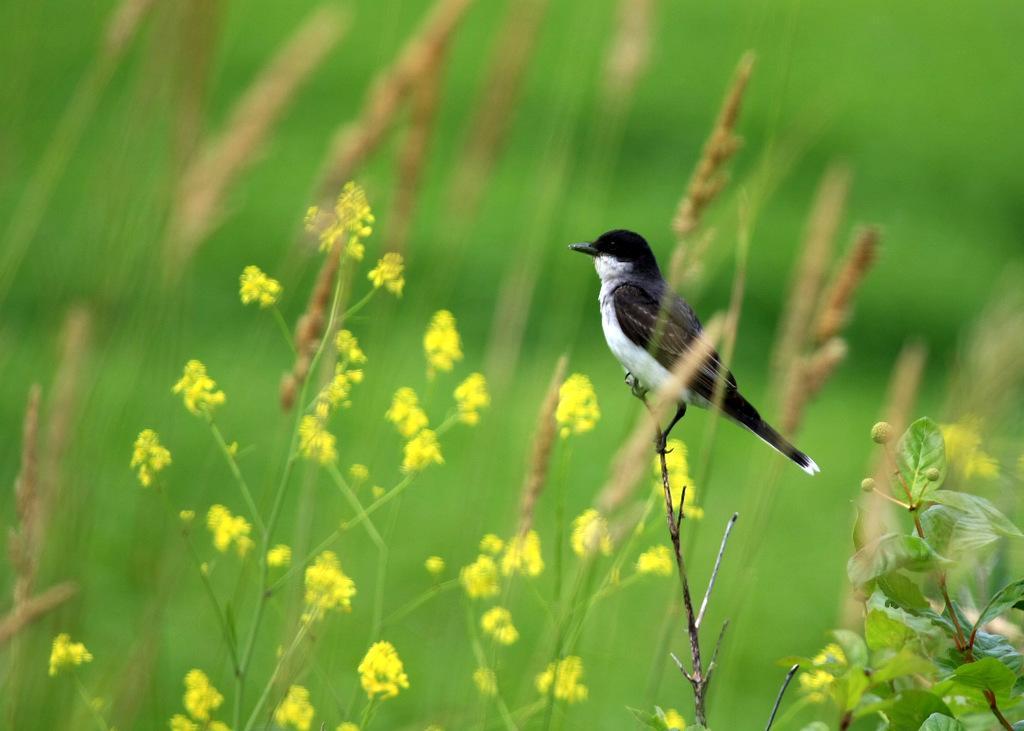Could you give a brief overview of what you see in this image? In this image there is a bird standing on the stick beside that there are some flower plants and grass. 